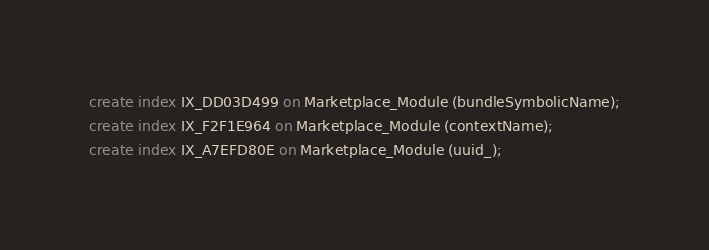Convert code to text. <code><loc_0><loc_0><loc_500><loc_500><_SQL_>create index IX_DD03D499 on Marketplace_Module (bundleSymbolicName);
create index IX_F2F1E964 on Marketplace_Module (contextName);
create index IX_A7EFD80E on Marketplace_Module (uuid_);</code> 